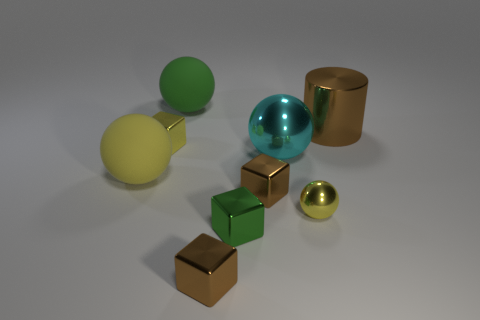Do the thing that is to the right of the tiny shiny ball and the small metal ball have the same color?
Keep it short and to the point. No. How many green matte things are behind the rubber thing in front of the large green rubber thing?
Offer a very short reply. 1. There is a shiny object that is the same size as the shiny cylinder; what is its color?
Provide a short and direct response. Cyan. There is a green object that is in front of the yellow matte object; what is it made of?
Give a very brief answer. Metal. What is the large thing that is both behind the large cyan sphere and to the left of the large brown object made of?
Your response must be concise. Rubber. Is the size of the matte ball that is in front of the green rubber sphere the same as the brown metal cylinder?
Offer a terse response. Yes. What is the shape of the big brown shiny object?
Your answer should be very brief. Cylinder. What number of big brown metallic things are the same shape as the green metallic thing?
Keep it short and to the point. 0. What number of big things are both to the right of the tiny green metallic thing and left of the large brown cylinder?
Your answer should be compact. 1. What color is the cylinder?
Ensure brevity in your answer.  Brown. 